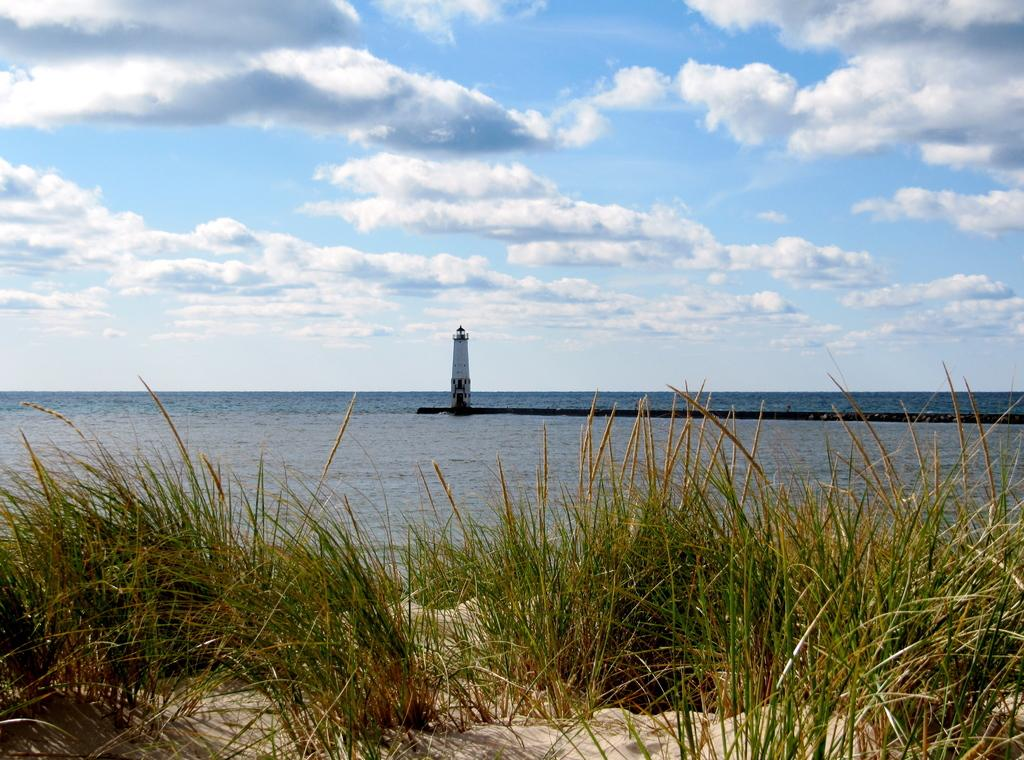What type of vegetation is present in the image? There is grass in the image. What else can be seen in the image besides grass? There is water and a lighthouse in the image. Where is the lighthouse located in the image? The lighthouse is in the middle of the image. How would you describe the sky in the image? The sky is blue and cloudy in the image. Can you see any zephyrs in the image? There are no zephyrs present in the image. Are there any balloons floating in the sky in the image? There are no balloons visible in the image. 